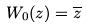Convert formula to latex. <formula><loc_0><loc_0><loc_500><loc_500>W _ { 0 } ( z ) = \overline { z }</formula> 